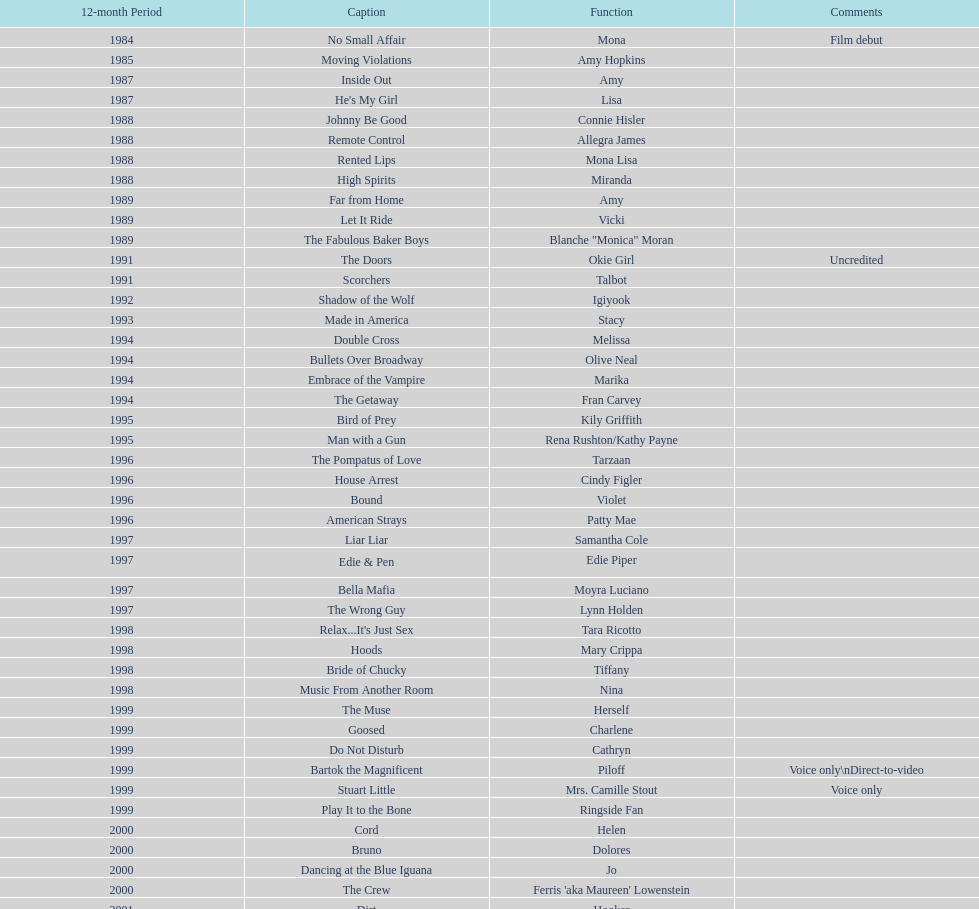Which film aired in 1994 and has marika as the role? Embrace of the Vampire. 